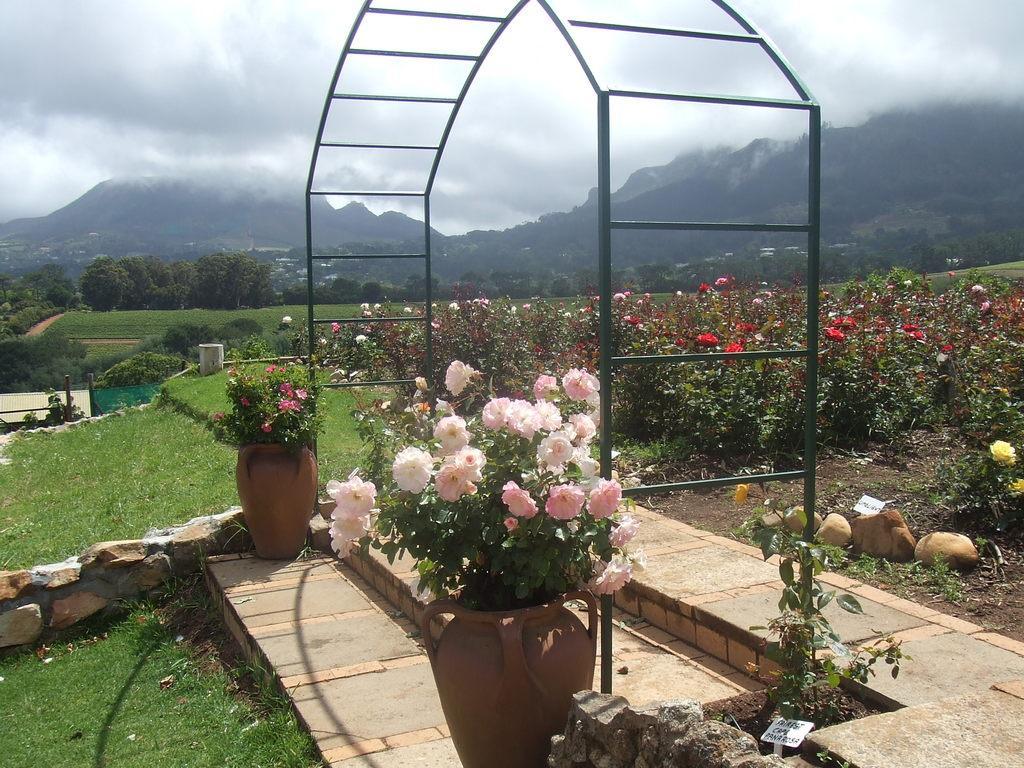How would you summarize this image in a sentence or two? In this picture we can see plants, flowers, pots, arch, grass, trees and mountain. In the background of the image we can see the sky with clouds. 